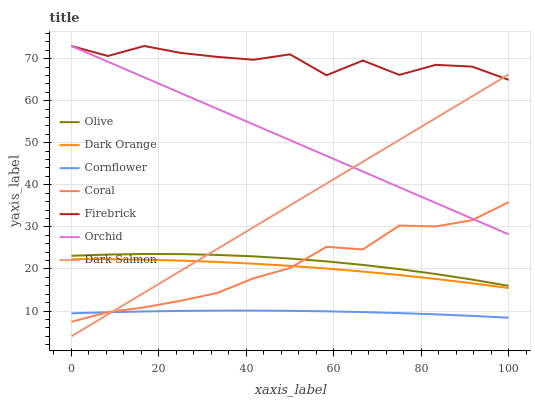Does Cornflower have the minimum area under the curve?
Answer yes or no. Yes. Does Firebrick have the maximum area under the curve?
Answer yes or no. Yes. Does Coral have the minimum area under the curve?
Answer yes or no. No. Does Coral have the maximum area under the curve?
Answer yes or no. No. Is Orchid the smoothest?
Answer yes or no. Yes. Is Firebrick the roughest?
Answer yes or no. Yes. Is Cornflower the smoothest?
Answer yes or no. No. Is Cornflower the roughest?
Answer yes or no. No. Does Dark Salmon have the lowest value?
Answer yes or no. Yes. Does Cornflower have the lowest value?
Answer yes or no. No. Does Orchid have the highest value?
Answer yes or no. Yes. Does Coral have the highest value?
Answer yes or no. No. Is Olive less than Firebrick?
Answer yes or no. Yes. Is Firebrick greater than Coral?
Answer yes or no. Yes. Does Dark Salmon intersect Orchid?
Answer yes or no. Yes. Is Dark Salmon less than Orchid?
Answer yes or no. No. Is Dark Salmon greater than Orchid?
Answer yes or no. No. Does Olive intersect Firebrick?
Answer yes or no. No. 